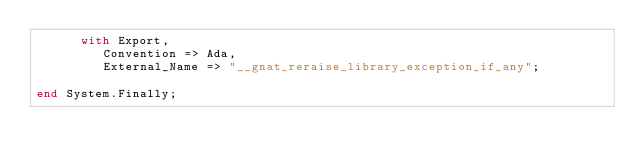<code> <loc_0><loc_0><loc_500><loc_500><_Ada_>      with Export,
         Convention => Ada,
         External_Name => "__gnat_reraise_library_exception_if_any";

end System.Finally;
</code> 